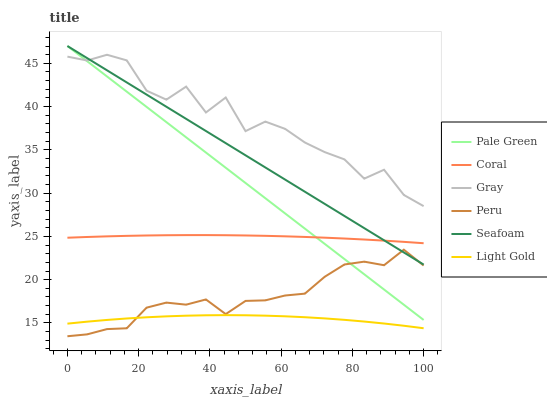Does Coral have the minimum area under the curve?
Answer yes or no. No. Does Coral have the maximum area under the curve?
Answer yes or no. No. Is Coral the smoothest?
Answer yes or no. No. Is Coral the roughest?
Answer yes or no. No. Does Coral have the lowest value?
Answer yes or no. No. Does Coral have the highest value?
Answer yes or no. No. Is Light Gold less than Coral?
Answer yes or no. Yes. Is Gray greater than Peru?
Answer yes or no. Yes. Does Light Gold intersect Coral?
Answer yes or no. No. 